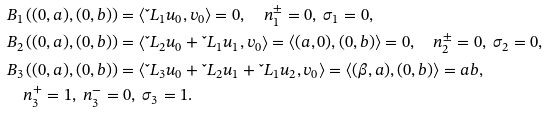Convert formula to latex. <formula><loc_0><loc_0><loc_500><loc_500>& B _ { 1 } \left ( ( 0 , a ) , ( 0 , b ) \right ) = \left \langle { \L L } _ { 1 } u _ { 0 } , v _ { 0 } \right \rangle = 0 , \quad n ^ { \pm } _ { 1 } = 0 , \ \sigma _ { 1 } = 0 , \\ & B _ { 2 } \left ( ( 0 , a ) , ( 0 , b ) \right ) = \left \langle { \L L } _ { 2 } u _ { 0 } + { \L L } _ { 1 } u _ { 1 } , v _ { 0 } \right \rangle = \langle ( a , 0 ) , ( 0 , b ) \rangle = 0 , \quad n _ { 2 } ^ { \pm } = 0 , \ \sigma _ { 2 } = 0 , \\ & B _ { 3 } \left ( ( 0 , a ) , ( 0 , b ) \right ) = \left \langle { \L L } _ { 3 } u _ { 0 } + { \L L } _ { 2 } u _ { 1 } + { \L L } _ { 1 } u _ { 2 } , v _ { 0 } \right \rangle = \left \langle ( \beta , a ) , ( 0 , b ) \right \rangle = a b , \\ & \quad n _ { 3 } ^ { + } = 1 , \ n _ { 3 } ^ { - } = 0 , \ \sigma _ { 3 } = 1 .</formula> 